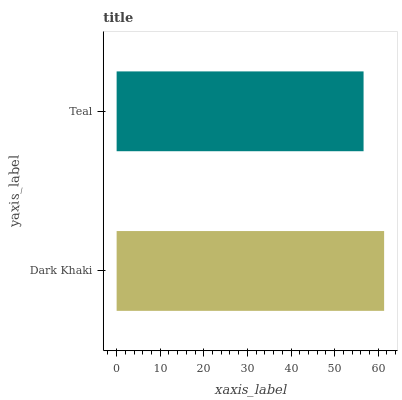Is Teal the minimum?
Answer yes or no. Yes. Is Dark Khaki the maximum?
Answer yes or no. Yes. Is Teal the maximum?
Answer yes or no. No. Is Dark Khaki greater than Teal?
Answer yes or no. Yes. Is Teal less than Dark Khaki?
Answer yes or no. Yes. Is Teal greater than Dark Khaki?
Answer yes or no. No. Is Dark Khaki less than Teal?
Answer yes or no. No. Is Dark Khaki the high median?
Answer yes or no. Yes. Is Teal the low median?
Answer yes or no. Yes. Is Teal the high median?
Answer yes or no. No. Is Dark Khaki the low median?
Answer yes or no. No. 